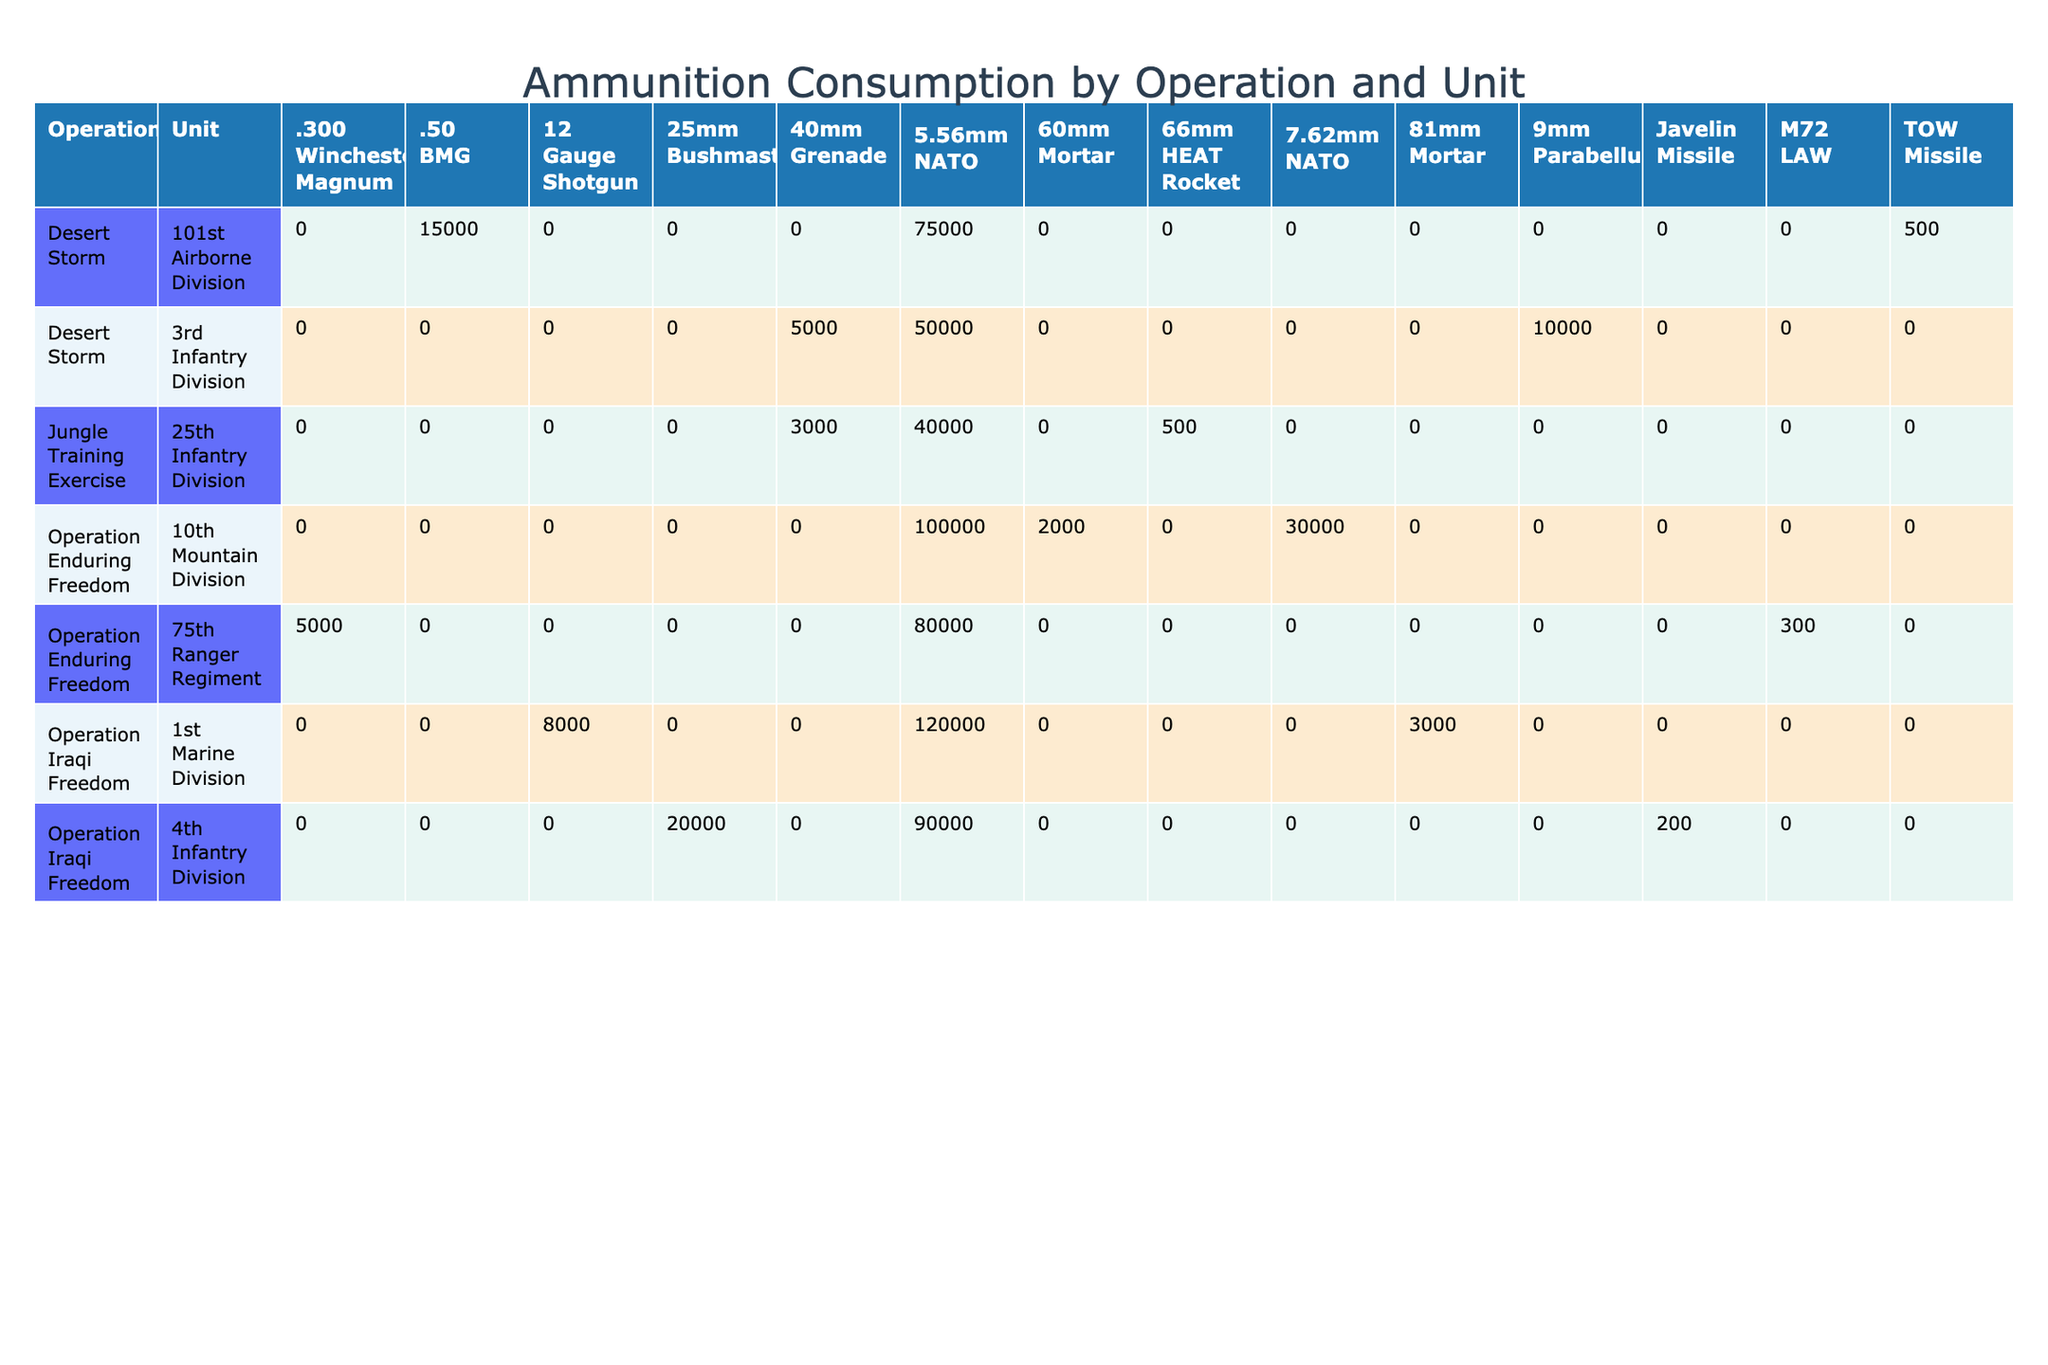What is the total number of rounds consumed by the 1st Marine Division during Operation Iraqi Freedom? The 1st Marine Division consumed 120,000 rounds of 5.56mm NATO, 8,000 rounds of 12 Gauge Shotgun, and 3,000 rounds of 81mm Mortar. Summing these values gives 120,000 + 8,000 + 3,000 = 131,000 rounds.
Answer: 131,000 Which unit had the highest ammunition consumption in Operation Enduring Freedom? The 10th Mountain Division consumed 100,000 rounds of 5.56mm NATO, while the 75th Ranger Regiment consumed 80,000 rounds of the same type. Therefore, the 10th Mountain Division had the highest ammunition consumption in Operation Enduring Freedom.
Answer: 10th Mountain Division How many different types of ammunition were consumed by the 3rd Infantry Division in Desert Storm? The 3rd Infantry Division consumed three types of ammunition: 5.56mm NATO, 9mm Parabellum, and 40mm Grenade. Therefore, the total is three different types of ammunition.
Answer: 3 What is the average resupply frequency (in days) for the 25th Infantry Division during the Jungle Training Exercise? The resupply frequencies for the 25th Infantry Division were 3, 4, and 5 days. Summing these gives 3 + 4 + 5 = 12 days. There are three ammunition types, so the average is 12 / 3 = 4 days.
Answer: 4 Did the 101st Airborne Division consume more rounds of 5.56mm NATO or .50 BMG in Desert Storm? The 101st Airborne Division consumed 75,000 rounds of 5.56mm NATO and 15,000 rounds of .50 BMG. Since 75,000 is greater than 15,000, they consumed more rounds of 5.56mm NATO.
Answer: Yes Which operation had the longest duration of 60 days, and what units were involved? The only operation with a duration of 60 days is Operation Iraqi Freedom. The units involved are the 1st Marine Division and the 4th Infantry Division.
Answer: Operation Iraqi Freedom with 1st Marine Division and 4th Infantry Division What is the total ammunition consumption across all operations for 5.56mm NATO rounds? The total consumption for 5.56mm NATO is: 50,000 (3rd Infantry Division) + 75,000 (101st Airborne Division) + 100,000 (10th Mountain Division) + 80,000 (75th Ranger Regiment) + 120,000 (1st Marine Division) + 90,000 (4th Infantry Division) + 40,000 (25th Infantry Division) = 555,000 rounds.
Answer: 555,000 Which terrain type saw the least amount of rounds consumed in total? The Jungle Training Exercise had the least rounds consumed with 40,000 (5.56mm NATO) + 3,000 (40mm Grenade) + 500 (66mm HEAT Rocket) = 43,500 rounds, which is less than any other terrain total.
Answer: Jungle What is the maximum number of rounds consumed within a single operational day across all units? In Operation Iraqi Freedom, the 1st Marine Division consumed 120,000 rounds over 60 days, resulting in an average of 2,000 rounds per operational day. However, the 5.56mm NATO rounds collectively for 1st Marine Division, which is the maximum, pertained to multiple units and aggregated would exceed individual performances from other operations. The highest recorded in a single consumption for an operation was from the 5.56mm NATO with 100,000 rounds across 30 days from the 10th Mountain Division which results in a considerably higher operational day consumption average of 3333.33 rounds/day. That's the maximum derived from the dataset with specifics on multiple units considered.
Answer: 3,333.33 rounds per day 